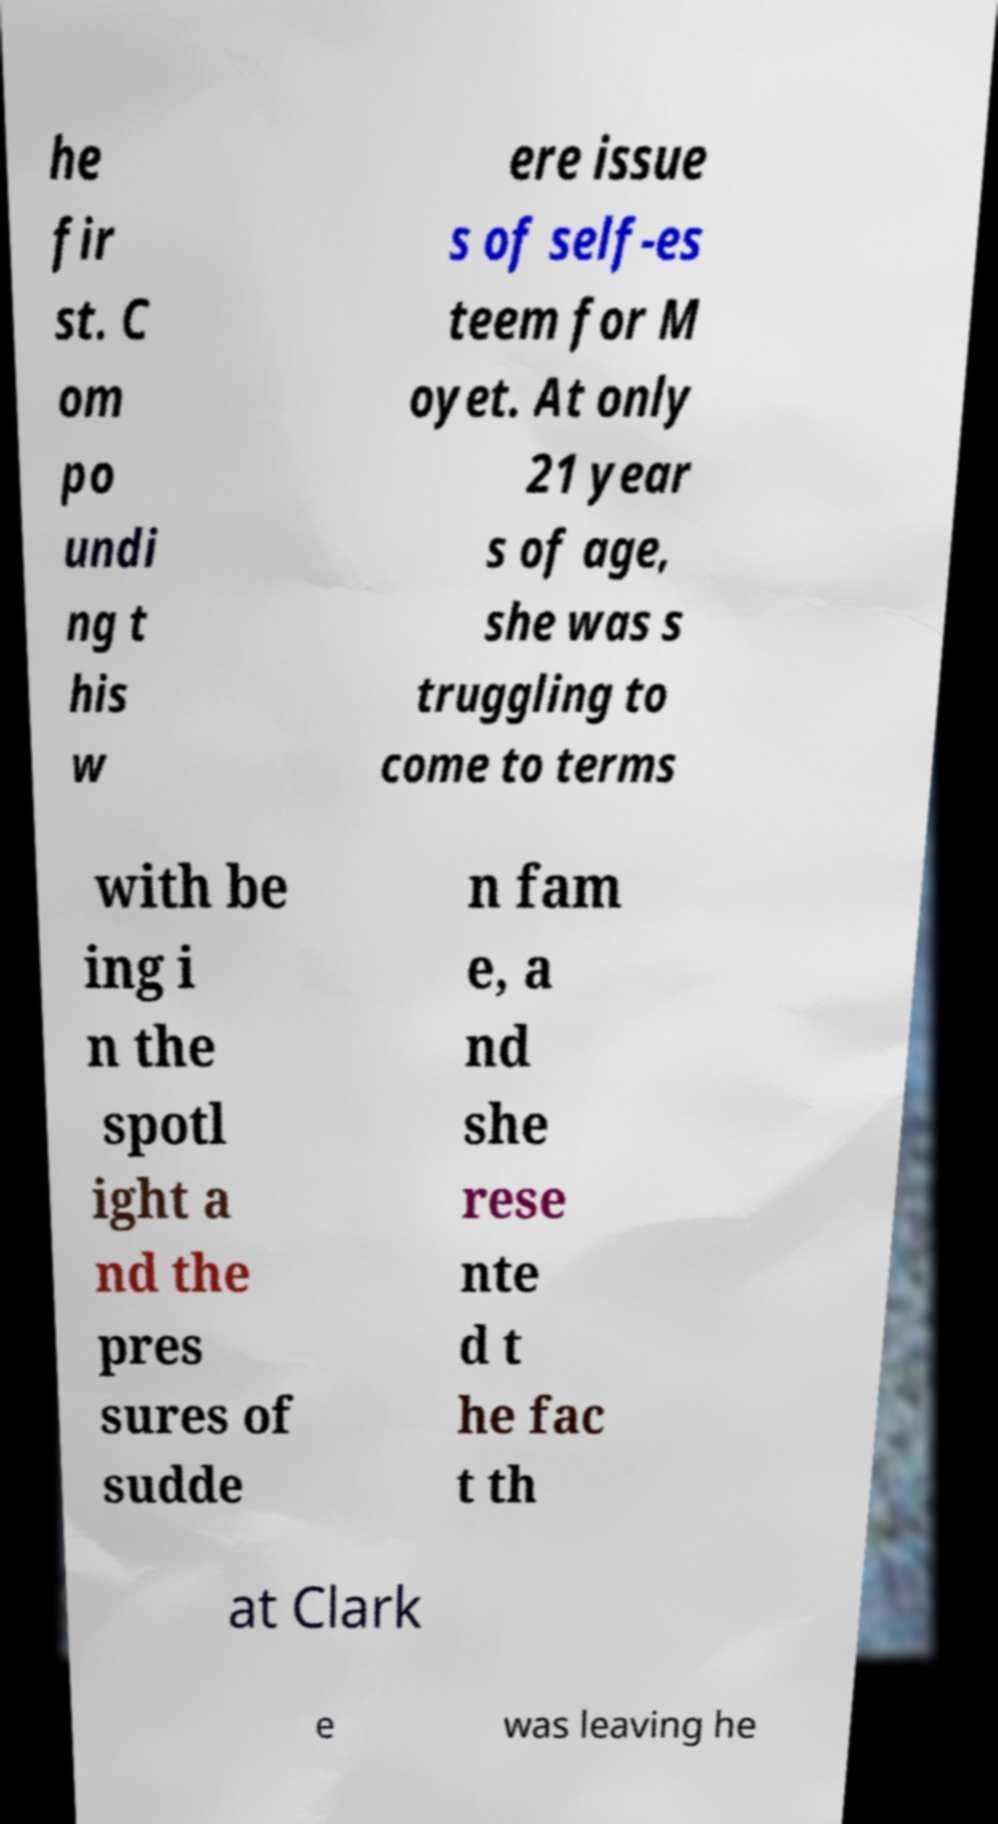There's text embedded in this image that I need extracted. Can you transcribe it verbatim? he fir st. C om po undi ng t his w ere issue s of self-es teem for M oyet. At only 21 year s of age, she was s truggling to come to terms with be ing i n the spotl ight a nd the pres sures of sudde n fam e, a nd she rese nte d t he fac t th at Clark e was leaving he 